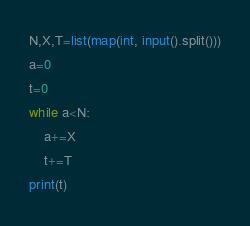Convert code to text. <code><loc_0><loc_0><loc_500><loc_500><_Python_>N,X,T=list(map(int, input().split()))
a=0
t=0
while a<N:
    a+=X
    t+=T
print(t)</code> 